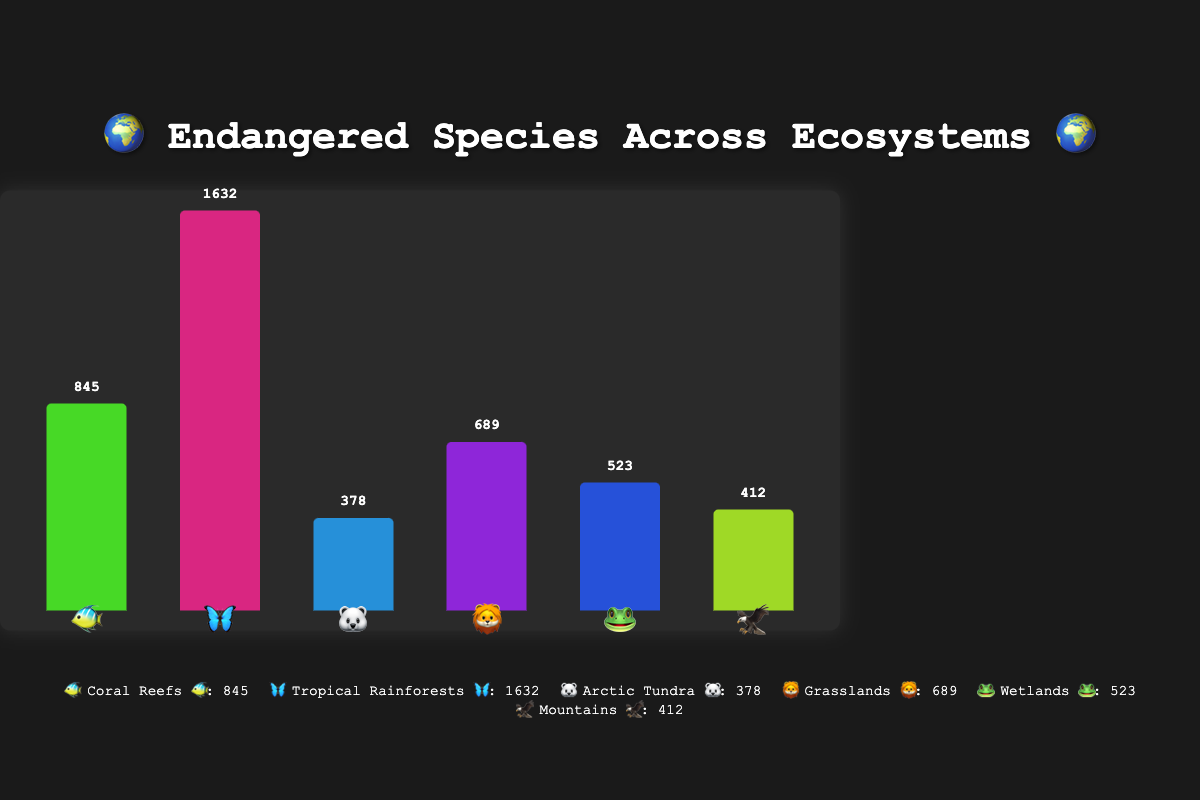What's the title of the chart? The title is usually displayed at the top of the chart, and in this case, it reads "🌍 Endangered Species Across Ecosystems 🌍".
Answer: "🌍 Endangered Species Across Ecosystems 🌍" Which ecosystem has the most endangered species? By looking at the heights of the bars, you can see that the bar for "Tropical Rainforests 🦋" is the tallest, indicating it has the most endangered species.
Answer: Tropical Rainforests 🦋 How many ecosystems are represented in the chart? The chart has distinct bars for each ecosystem, and by counting these bars, the number of ecosystems can be determined. The legends also show six unique ecosystems.
Answer: 6 What's the total number of endangered species across all ecosystems? To find the total, sum the endangered species for each ecosystem: 845 (Coral Reefs) + 1632 (Tropical Rainforests) + 378 (Arctic Tundra) + 689 (Grasslands) + 523 (Wetlands) + 412 (Mountains).
Answer: 4479 Which ecosystems have more endangered species: Coral Reefs 🐠 or Wetlands 🐸? Compare the heights of the bars for Coral Reefs 🐠 and Wetlands 🐸. Coral Reefs 🐠 have 845 endangered species, while Wetlands 🐸 have 523.
Answer: Coral Reefs 🐠 How many more endangered species are in Grasslands 🦁 compared to Mountains 🦅? Subtract the number of endangered species in Mountains 🦅 (412) from Grasslands 🦁 (689).
Answer: 277 What percentage of the total endangered species are found in Tropical Rainforests 🦋? Divide the number of endangered species in Tropical Rainforests (1632) by the total number of endangered species (4479) and multiply by 100: (1632 / 4479) * 100.
Answer: Approximately 36.4% Which ecosystem has the fewest endangered species? The shortest bar represents the ecosystem with the fewest endangered species, which corresponds to Arctic Tundra 🐻‍❄️ with 378 species.
Answer: Arctic Tundra 🐻‍❄️ 